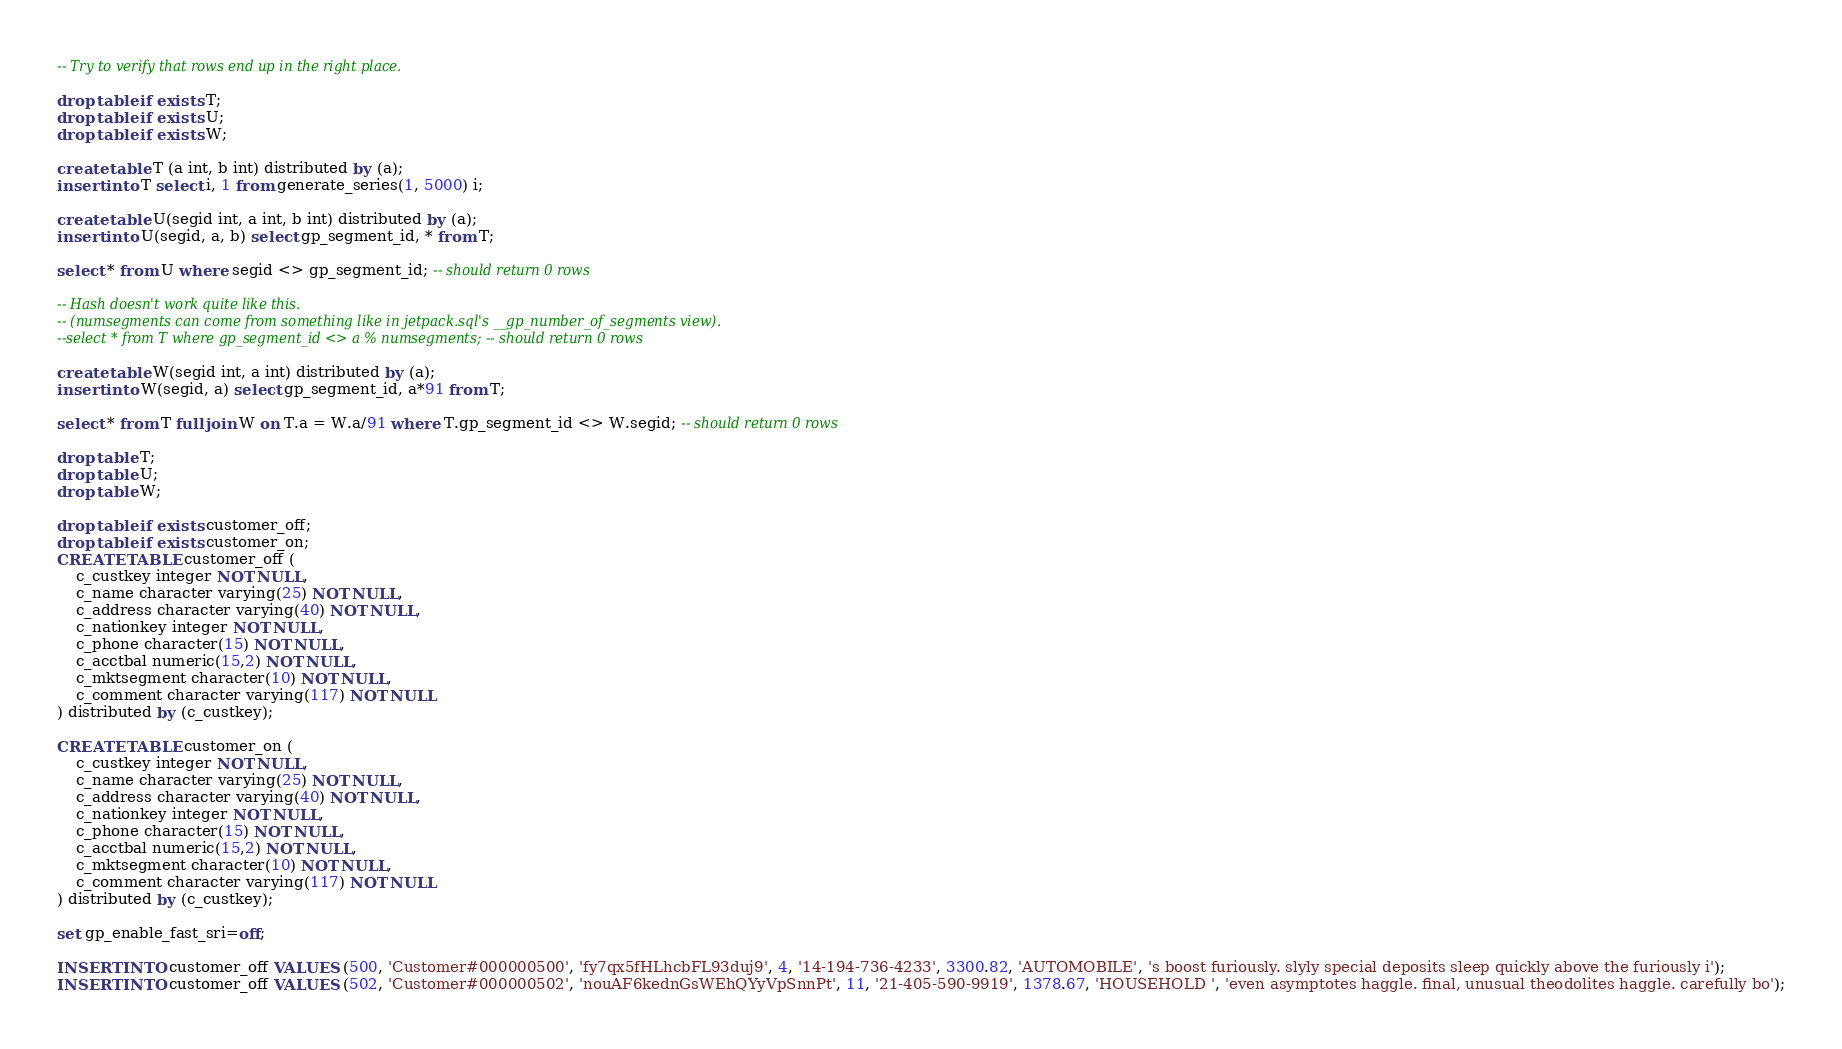Convert code to text. <code><loc_0><loc_0><loc_500><loc_500><_SQL_>-- Try to verify that rows end up in the right place.

drop table if exists T;
drop table if exists U;
drop table if exists W;

create table T (a int, b int) distributed by (a);
insert into T select i, 1 from generate_series(1, 5000) i;

create table U(segid int, a int, b int) distributed by (a);
insert into U(segid, a, b) select gp_segment_id, * from T;

select * from U where segid <> gp_segment_id; -- should return 0 rows

-- Hash doesn't work quite like this.
-- (numsegments can come from something like in jetpack.sql's __gp_number_of_segments view).
--select * from T where gp_segment_id <> a % numsegments; -- should return 0 rows

create table W(segid int, a int) distributed by (a);
insert into W(segid, a) select gp_segment_id, a*91 from T;

select * from T full join W on T.a = W.a/91 where T.gp_segment_id <> W.segid; -- should return 0 rows 

drop table T;
drop table U;
drop table W;

drop table if exists customer_off;
drop table if exists customer_on;
CREATE TABLE customer_off (
    c_custkey integer NOT NULL,
    c_name character varying(25) NOT NULL,
    c_address character varying(40) NOT NULL,
    c_nationkey integer NOT NULL,
    c_phone character(15) NOT NULL,
    c_acctbal numeric(15,2) NOT NULL,
    c_mktsegment character(10) NOT NULL,
    c_comment character varying(117) NOT NULL
) distributed by (c_custkey);

CREATE TABLE customer_on (
    c_custkey integer NOT NULL,
    c_name character varying(25) NOT NULL,
    c_address character varying(40) NOT NULL,
    c_nationkey integer NOT NULL,
    c_phone character(15) NOT NULL,
    c_acctbal numeric(15,2) NOT NULL,
    c_mktsegment character(10) NOT NULL,
    c_comment character varying(117) NOT NULL
) distributed by (c_custkey);

set gp_enable_fast_sri=off;

INSERT INTO customer_off VALUES (500, 'Customer#000000500', 'fy7qx5fHLhcbFL93duj9', 4, '14-194-736-4233', 3300.82, 'AUTOMOBILE', 's boost furiously. slyly special deposits sleep quickly above the furiously i');
INSERT INTO customer_off VALUES (502, 'Customer#000000502', 'nouAF6kednGsWEhQYyVpSnnPt', 11, '21-405-590-9919', 1378.67, 'HOUSEHOLD ', 'even asymptotes haggle. final, unusual theodolites haggle. carefully bo');</code> 